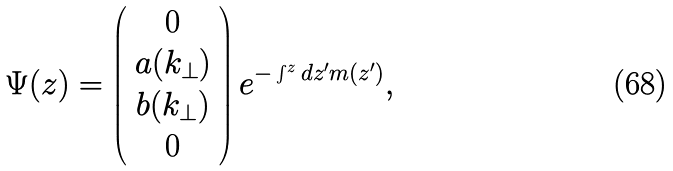Convert formula to latex. <formula><loc_0><loc_0><loc_500><loc_500>\Psi ( z ) = \left ( \begin{array} { c } 0 \\ a ( k _ { \perp } ) \\ b ( k _ { \perp } ) \\ 0 \end{array} \right ) e ^ { - \int ^ { z } d z ^ { \prime } m ( z ^ { \prime } ) } ,</formula> 